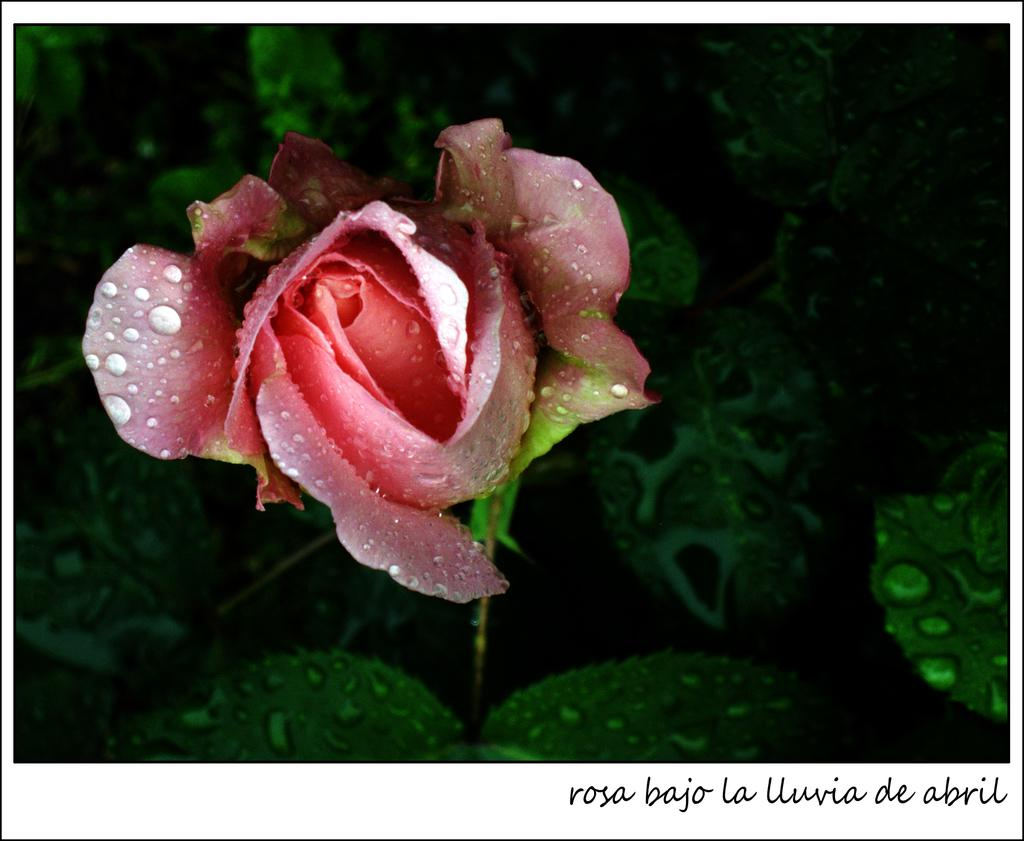What is the main subject of the image? There is a flower in the image. Can you describe the colors of the flower? The flower has pink and red colors. Is the flower connected to any other object in the image? Yes, the flower is attached to a tree. What is the color of the tree? The tree has a green color. Are there any additional features on the flower or tree? Yes, there are water drops on the flower and the tree. How does the yak contribute to the beauty of the flower in the image? There is no yak present in the image, so it cannot contribute to the beauty of the flower. 